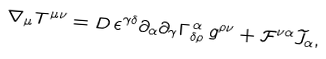Convert formula to latex. <formula><loc_0><loc_0><loc_500><loc_500>\nabla _ { \mu } T ^ { \mu \nu } = D \, \epsilon ^ { \gamma \delta } \partial _ { \alpha } \partial _ { \gamma } \Gamma _ { \delta \rho } ^ { \, \alpha } \, g ^ { \rho \nu } + \mathcal { F } ^ { \nu \alpha } \widetilde { J } _ { \alpha } ,</formula> 